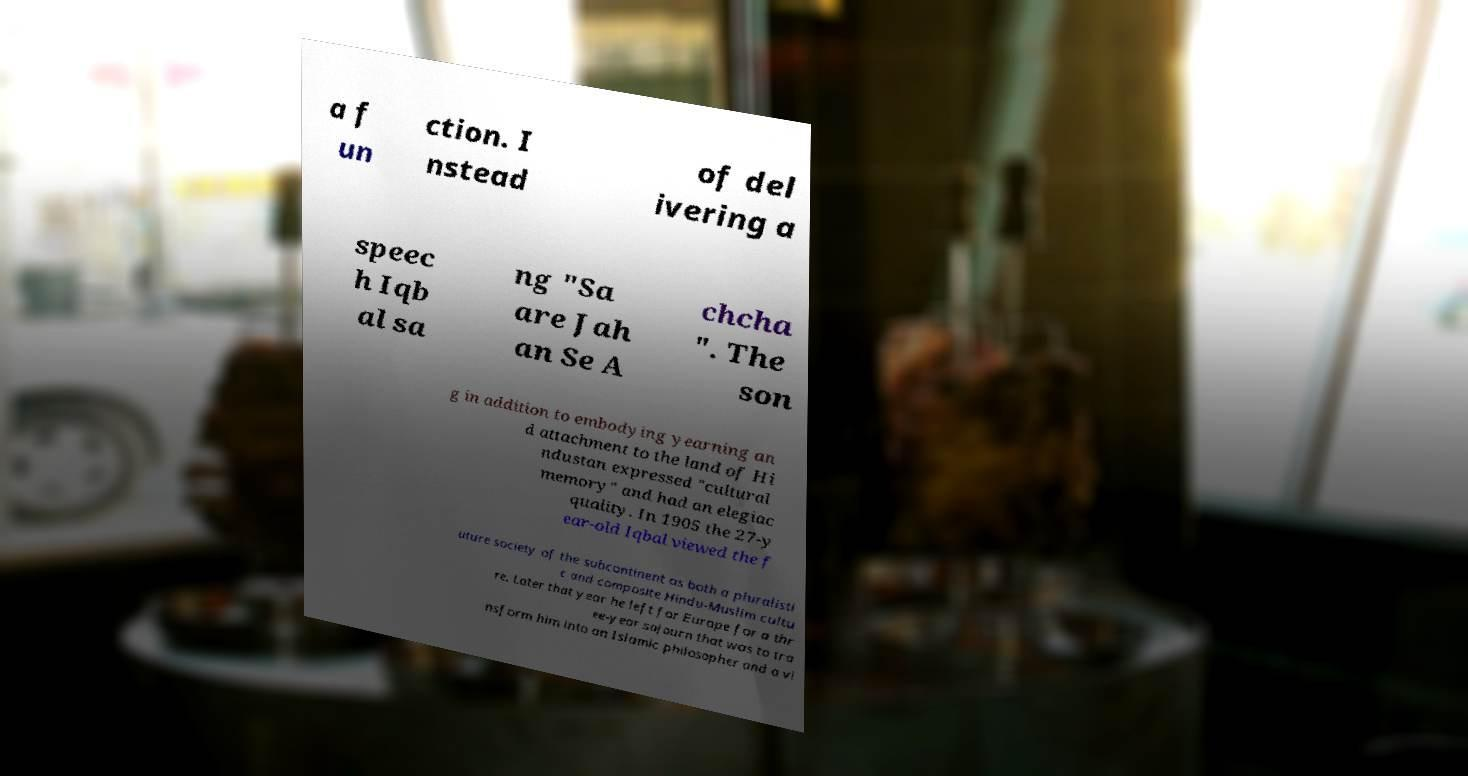Could you assist in decoding the text presented in this image and type it out clearly? a f un ction. I nstead of del ivering a speec h Iqb al sa ng "Sa are Jah an Se A chcha ". The son g in addition to embodying yearning an d attachment to the land of Hi ndustan expressed "cultural memory" and had an elegiac quality. In 1905 the 27-y ear-old Iqbal viewed the f uture society of the subcontinent as both a pluralisti c and composite Hindu-Muslim cultu re. Later that year he left for Europe for a thr ee-year sojourn that was to tra nsform him into an Islamic philosopher and a vi 